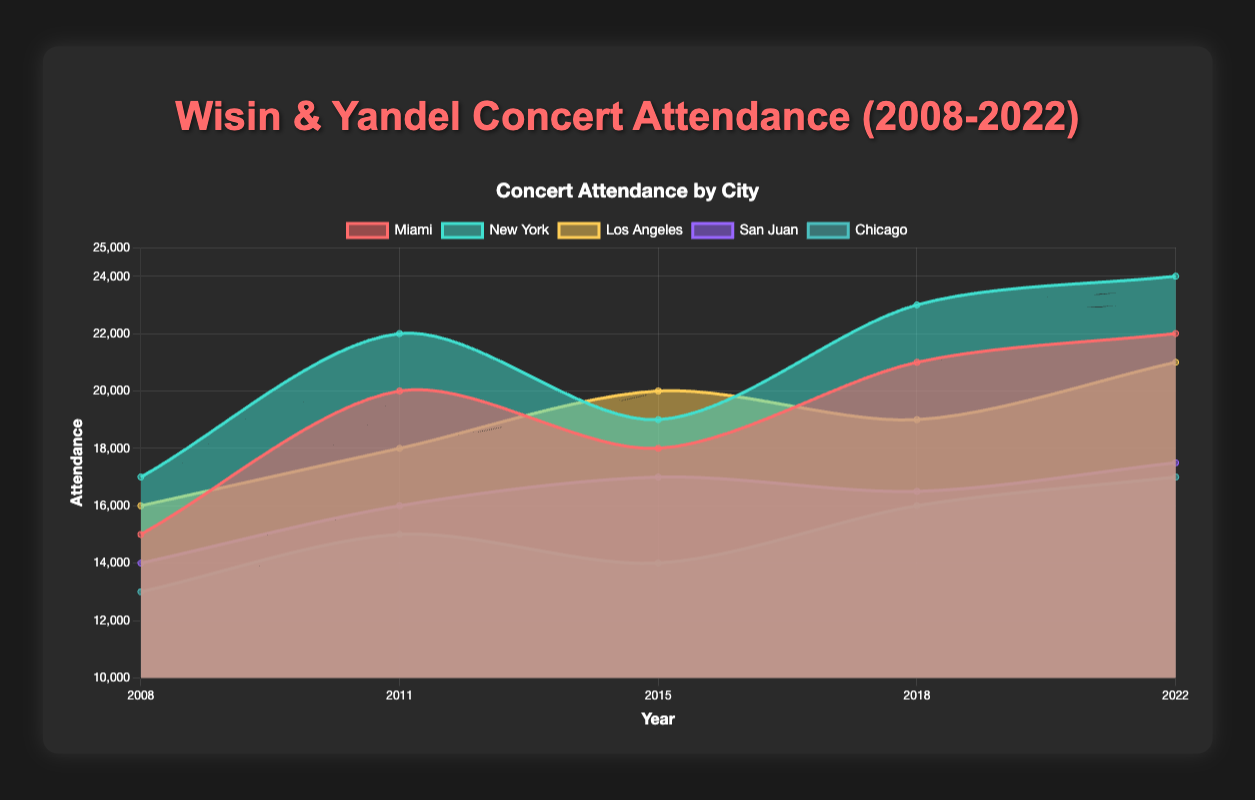question1 What is the title of the chart is "Wisin & Yandel Concert Attendance (2008-2022)", which is indicated at the top center of the chart.
Answer: Wisin & Yandel Concert Attendance (2008-2022) 